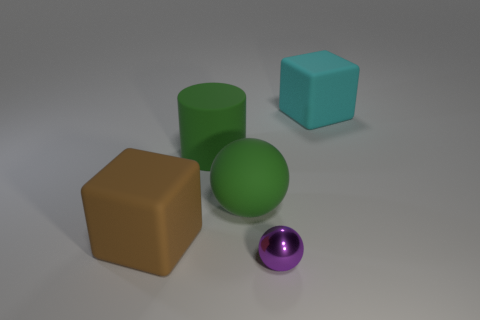Are there any red shiny objects of the same size as the green rubber cylinder?
Your answer should be compact. No. Do the block behind the big green cylinder and the large green cylinder have the same material?
Keep it short and to the point. Yes. Are there an equal number of green cylinders that are to the left of the small purple shiny thing and blocks that are in front of the green rubber ball?
Make the answer very short. Yes. The object that is on the right side of the big sphere and behind the metallic object has what shape?
Keep it short and to the point. Cube. There is a cyan block; what number of big rubber blocks are left of it?
Ensure brevity in your answer.  1. What number of other things are there of the same shape as the cyan matte thing?
Offer a very short reply. 1. Are there fewer rubber cylinders than small green matte cubes?
Give a very brief answer. No. There is a object that is both on the right side of the large green matte cylinder and on the left side of the tiny metallic sphere; how big is it?
Give a very brief answer. Large. There is a cube left of the big matte block right of the cube in front of the large cyan block; how big is it?
Your response must be concise. Large. How big is the green ball?
Keep it short and to the point. Large. 